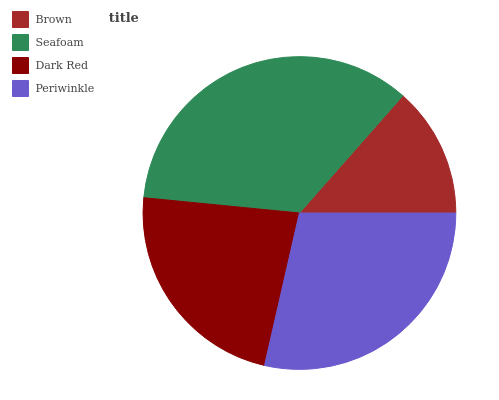Is Brown the minimum?
Answer yes or no. Yes. Is Seafoam the maximum?
Answer yes or no. Yes. Is Dark Red the minimum?
Answer yes or no. No. Is Dark Red the maximum?
Answer yes or no. No. Is Seafoam greater than Dark Red?
Answer yes or no. Yes. Is Dark Red less than Seafoam?
Answer yes or no. Yes. Is Dark Red greater than Seafoam?
Answer yes or no. No. Is Seafoam less than Dark Red?
Answer yes or no. No. Is Periwinkle the high median?
Answer yes or no. Yes. Is Dark Red the low median?
Answer yes or no. Yes. Is Dark Red the high median?
Answer yes or no. No. Is Seafoam the low median?
Answer yes or no. No. 